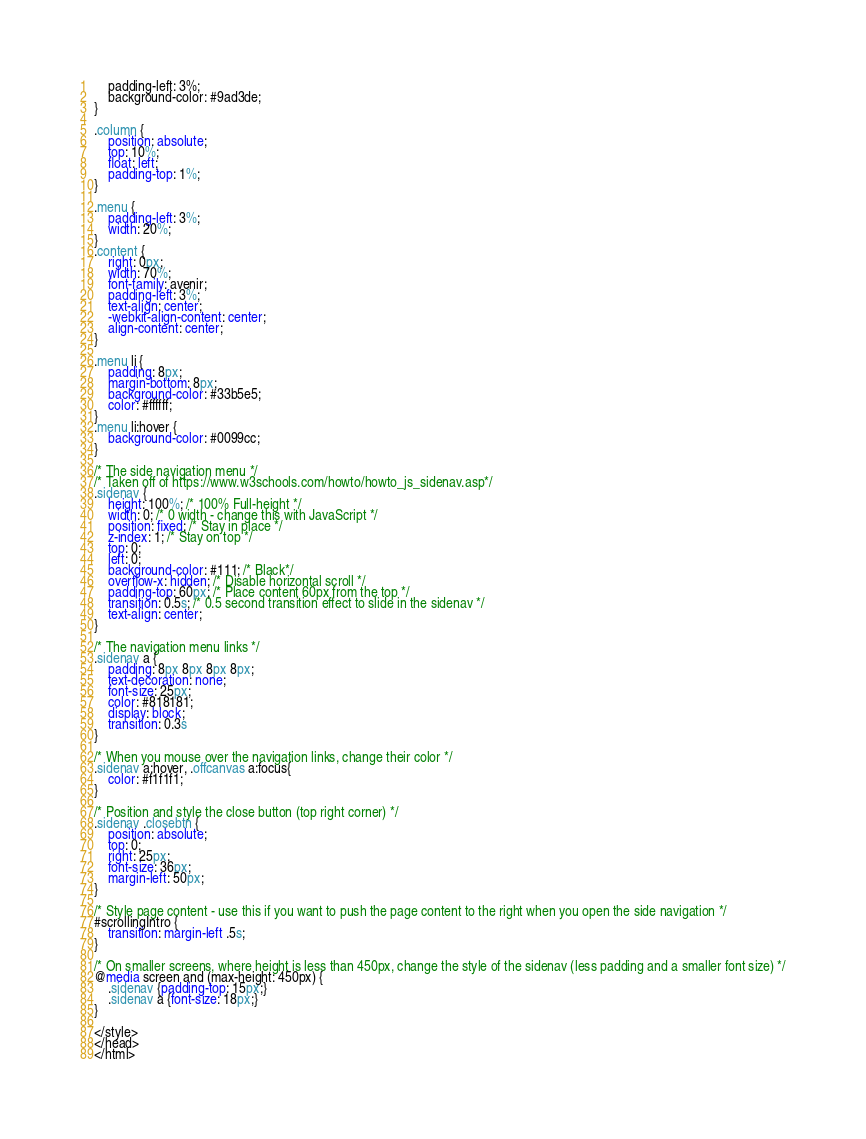<code> <loc_0><loc_0><loc_500><loc_500><_CSS_>	padding-left: 3%;
	background-color: #9ad3de;
}

.column {
	position: absolute;
	top: 10%;
    float: left;
    padding-top: 1%;
}

.menu {
	padding-left: 3%;
    width: 20%;
}
.content {
	right: 0px;
    width: 70%;
    font-family: avenir;
    padding-left: 3%;
    text-align: center;
    -webkit-align-content: center;
    align-content: center;
}

.menu li {
    padding: 8px;
    margin-bottom: 8px;
    background-color: #33b5e5;
    color: #ffffff;
}
.menu li:hover {
    background-color: #0099cc;
}

/* The side navigation menu */
/* Taken off of https://www.w3schools.com/howto/howto_js_sidenav.asp*/
.sidenav {
    height: 100%; /* 100% Full-height */
    width: 0; /* 0 width - change this with JavaScript */
    position: fixed; /* Stay in place */
    z-index: 1; /* Stay on top */
    top: 0;
    left: 0;
    background-color: #111; /* Black*/
    overflow-x: hidden; /* Disable horizontal scroll */
    padding-top: 60px; /* Place content 60px from the top */
    transition: 0.5s; /* 0.5 second transition effect to slide in the sidenav */
    text-align: center;
}

/* The navigation menu links */
.sidenav a {
    padding: 8px 8px 8px 8px;
    text-decoration: none;
    font-size: 25px;
    color: #818181;
    display: block;
    transition: 0.3s
}

/* When you mouse over the navigation links, change their color */
.sidenav a:hover, .offcanvas a:focus{
    color: #f1f1f1;
}

/* Position and style the close button (top right corner) */
.sidenav .closebtn {
    position: absolute;
    top: 0;
    right: 25px;
    font-size: 36px;
    margin-left: 50px;
}

/* Style page content - use this if you want to push the page content to the right when you open the side navigation */
#scrollingIntro {
    transition: margin-left .5s;
}

/* On smaller screens, where height is less than 450px, change the style of the sidenav (less padding and a smaller font size) */
@media screen and (max-height: 450px) {
    .sidenav {padding-top: 15px;}
    .sidenav a {font-size: 18px;}
}

</style>
</head>
</html></code> 